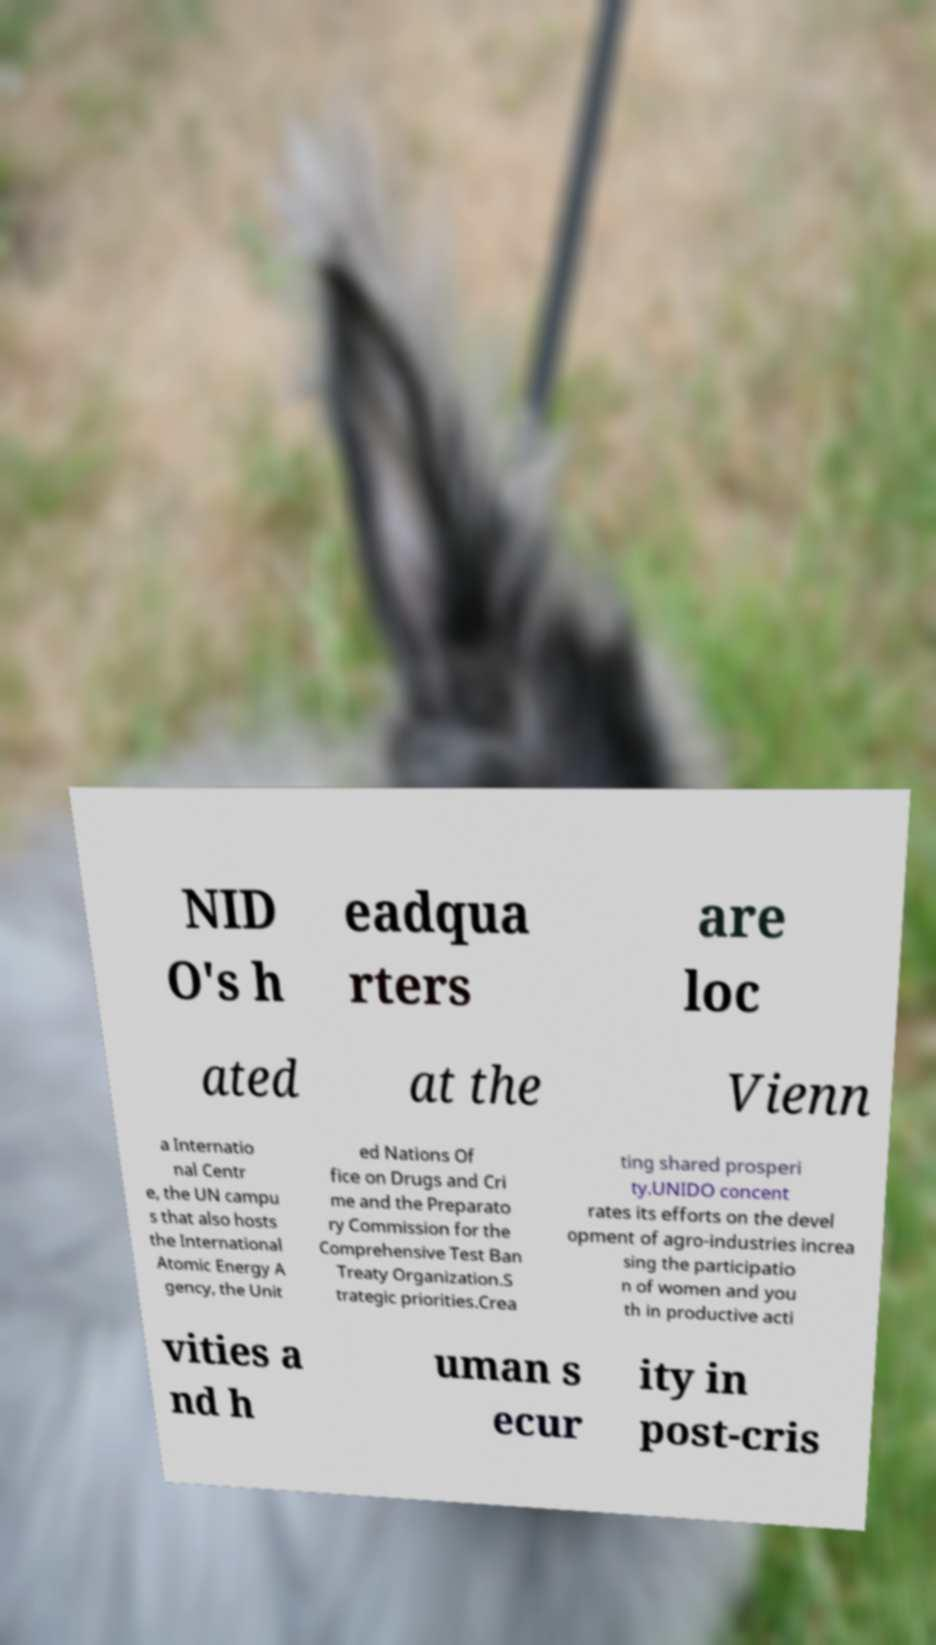There's text embedded in this image that I need extracted. Can you transcribe it verbatim? NID O's h eadqua rters are loc ated at the Vienn a Internatio nal Centr e, the UN campu s that also hosts the International Atomic Energy A gency, the Unit ed Nations Of fice on Drugs and Cri me and the Preparato ry Commission for the Comprehensive Test Ban Treaty Organization.S trategic priorities.Crea ting shared prosperi ty.UNIDO concent rates its efforts on the devel opment of agro-industries increa sing the participatio n of women and you th in productive acti vities a nd h uman s ecur ity in post-cris 